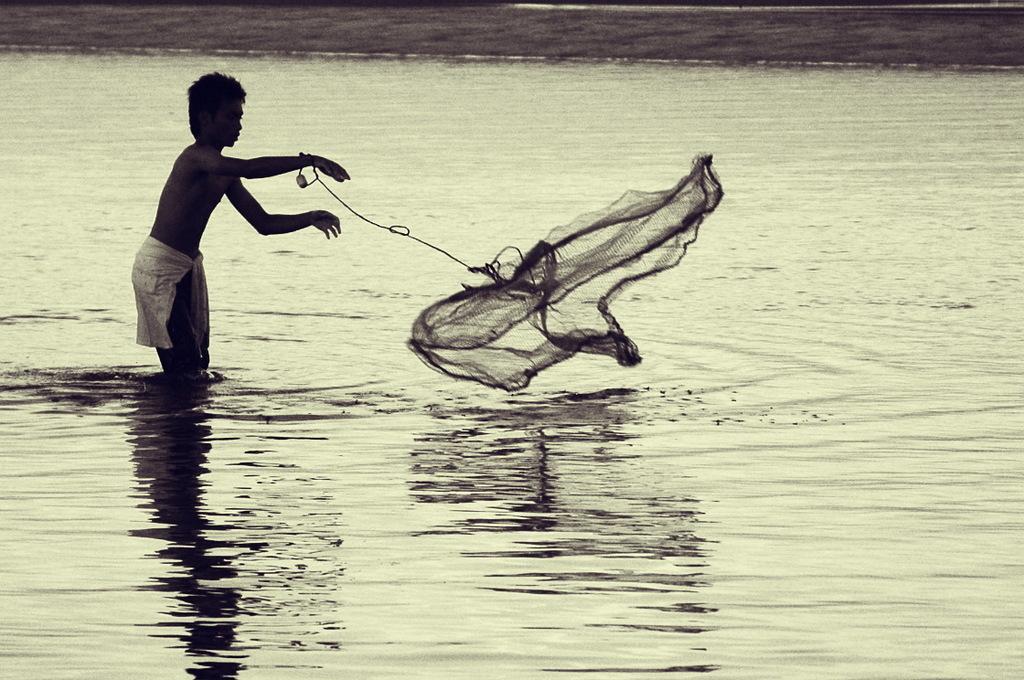How would you summarize this image in a sentence or two? In this picture we can see a boy standing in water and holding a fishing net with his hand. 